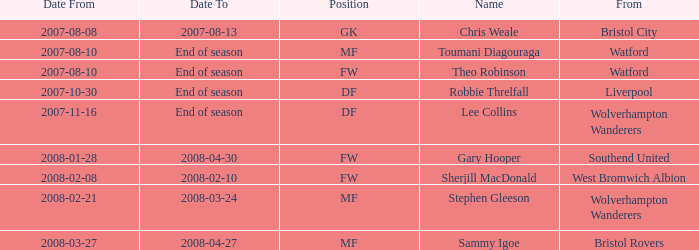What was the from for the Date From of 2007-08-08? Bristol City. 